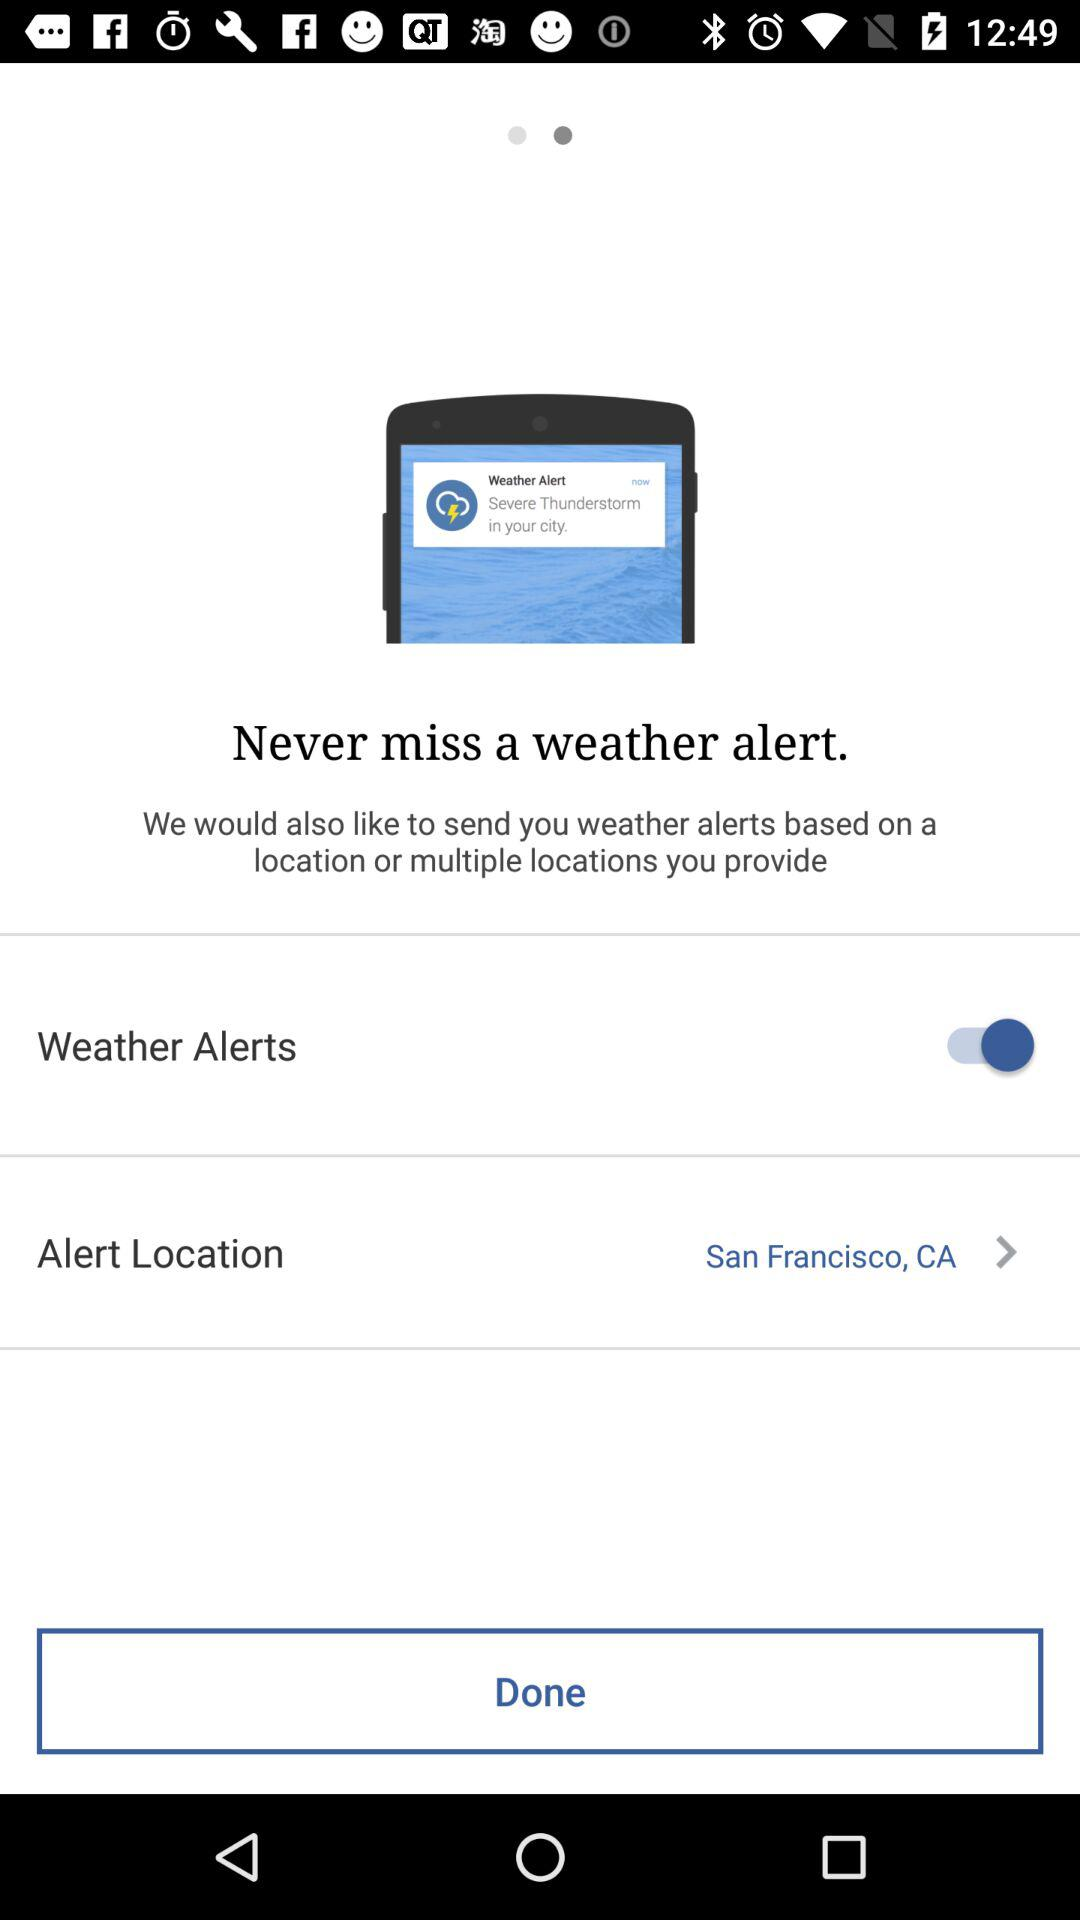What is the status of "Weather Alerts"? The status is "on". 